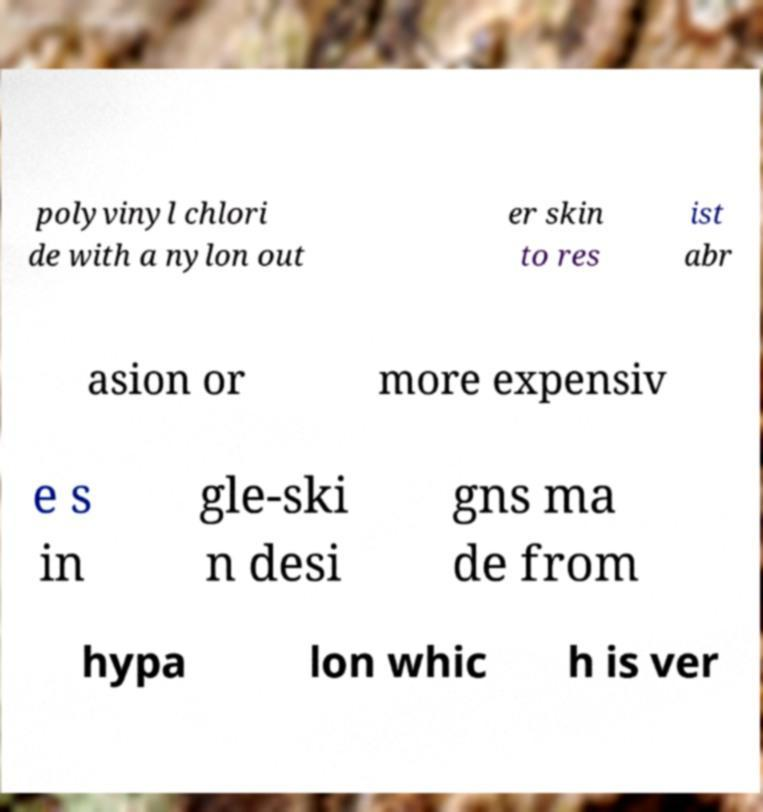Could you extract and type out the text from this image? polyvinyl chlori de with a nylon out er skin to res ist abr asion or more expensiv e s in gle-ski n desi gns ma de from hypa lon whic h is ver 